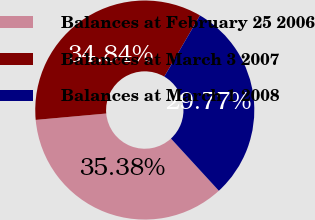<chart> <loc_0><loc_0><loc_500><loc_500><pie_chart><fcel>Balances at February 25 2006<fcel>Balances at March 3 2007<fcel>Balances at March 1 2008<nl><fcel>35.38%<fcel>34.84%<fcel>29.77%<nl></chart> 